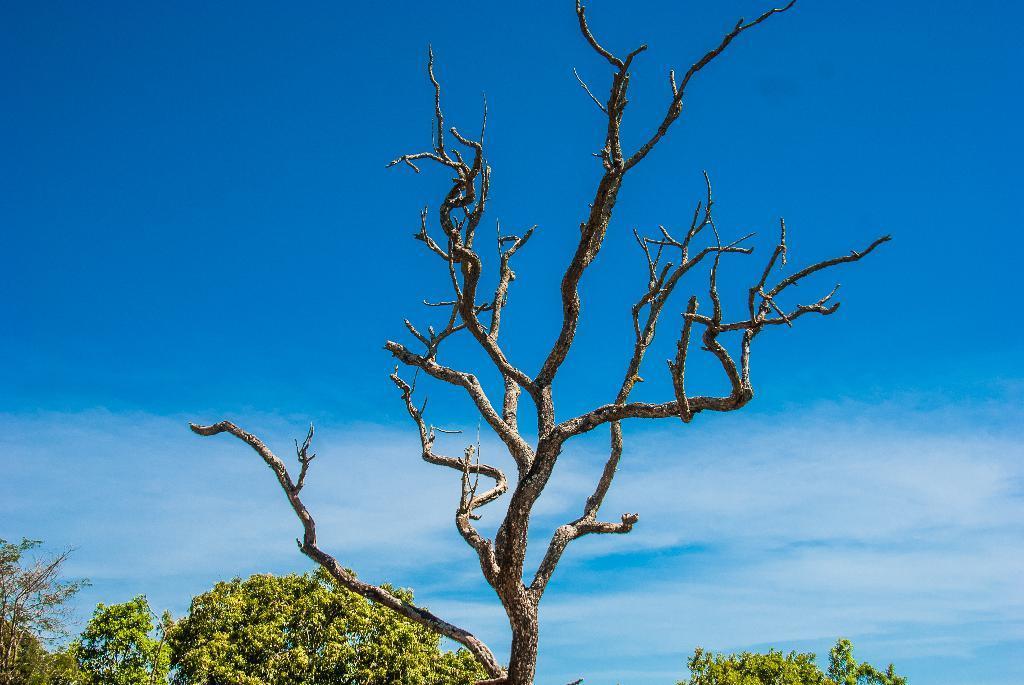Could you give a brief overview of what you see in this image? In this picture we can see trees in the front, there is the sky in the background. 